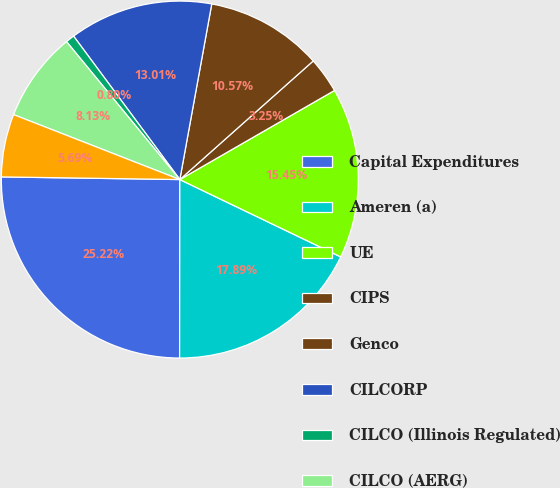Convert chart. <chart><loc_0><loc_0><loc_500><loc_500><pie_chart><fcel>Capital Expenditures<fcel>Ameren (a)<fcel>UE<fcel>CIPS<fcel>Genco<fcel>CILCORP<fcel>CILCO (Illinois Regulated)<fcel>CILCO (AERG)<fcel>IP<nl><fcel>25.22%<fcel>17.89%<fcel>15.45%<fcel>3.25%<fcel>10.57%<fcel>13.01%<fcel>0.8%<fcel>8.13%<fcel>5.69%<nl></chart> 